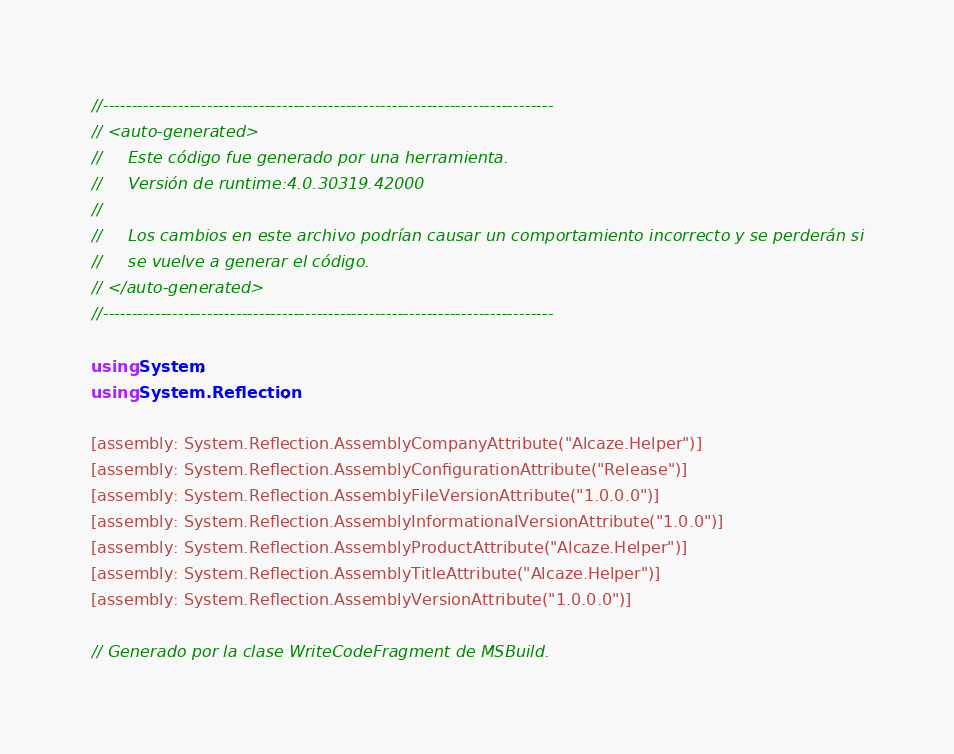Convert code to text. <code><loc_0><loc_0><loc_500><loc_500><_C#_>//------------------------------------------------------------------------------
// <auto-generated>
//     Este código fue generado por una herramienta.
//     Versión de runtime:4.0.30319.42000
//
//     Los cambios en este archivo podrían causar un comportamiento incorrecto y se perderán si
//     se vuelve a generar el código.
// </auto-generated>
//------------------------------------------------------------------------------

using System;
using System.Reflection;

[assembly: System.Reflection.AssemblyCompanyAttribute("Alcaze.Helper")]
[assembly: System.Reflection.AssemblyConfigurationAttribute("Release")]
[assembly: System.Reflection.AssemblyFileVersionAttribute("1.0.0.0")]
[assembly: System.Reflection.AssemblyInformationalVersionAttribute("1.0.0")]
[assembly: System.Reflection.AssemblyProductAttribute("Alcaze.Helper")]
[assembly: System.Reflection.AssemblyTitleAttribute("Alcaze.Helper")]
[assembly: System.Reflection.AssemblyVersionAttribute("1.0.0.0")]

// Generado por la clase WriteCodeFragment de MSBuild.

</code> 